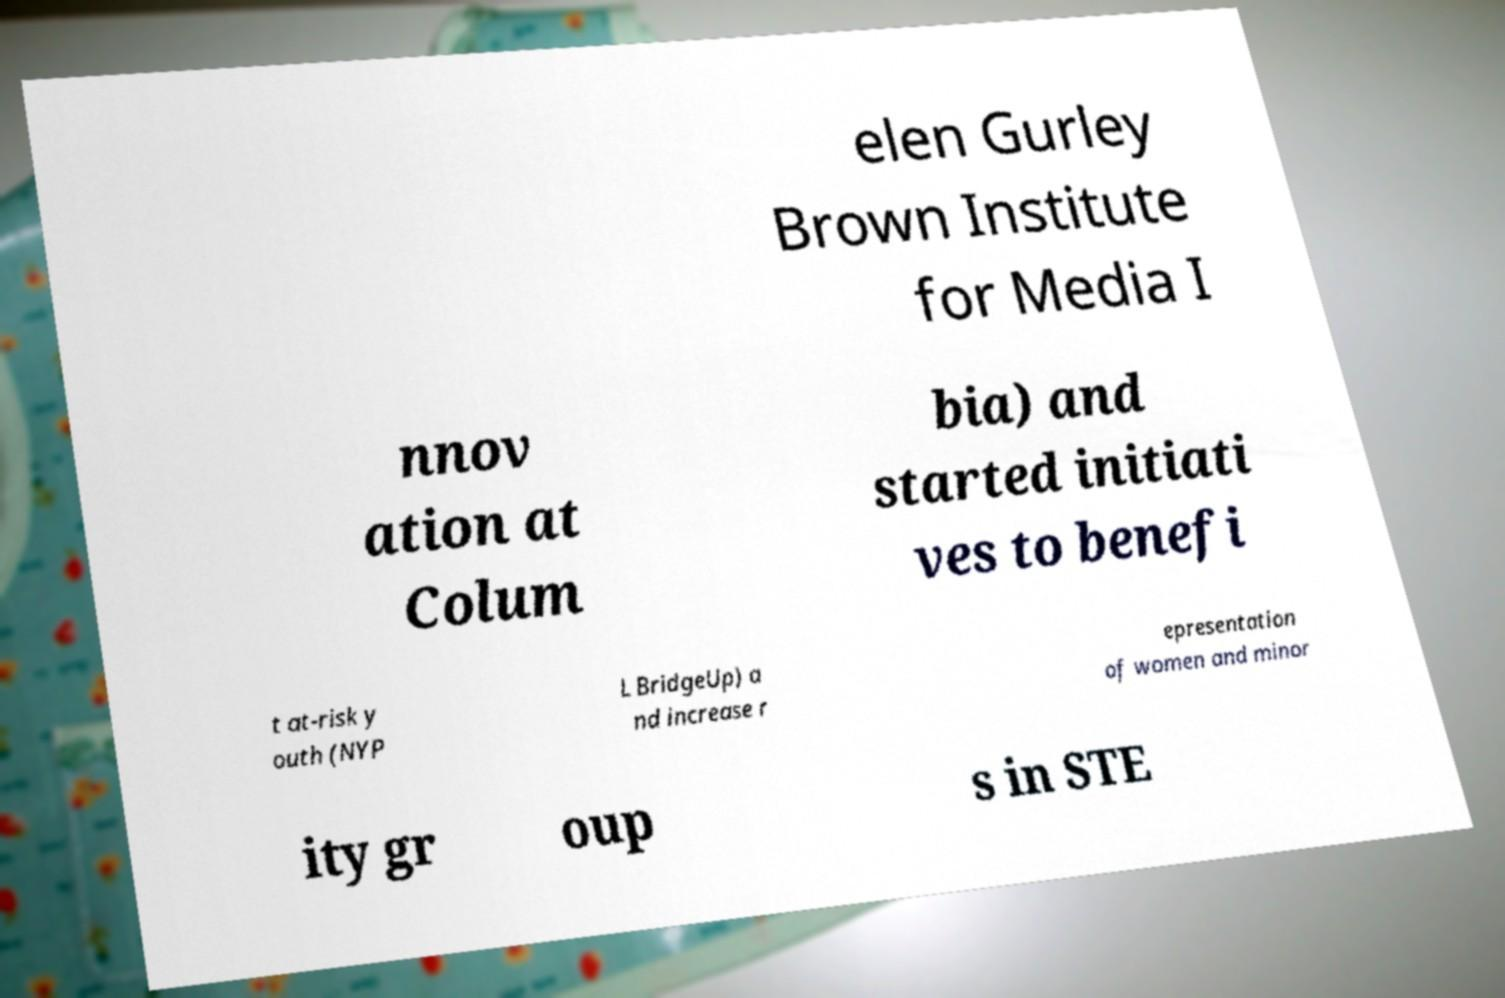Could you extract and type out the text from this image? elen Gurley Brown Institute for Media I nnov ation at Colum bia) and started initiati ves to benefi t at-risk y outh (NYP L BridgeUp) a nd increase r epresentation of women and minor ity gr oup s in STE 